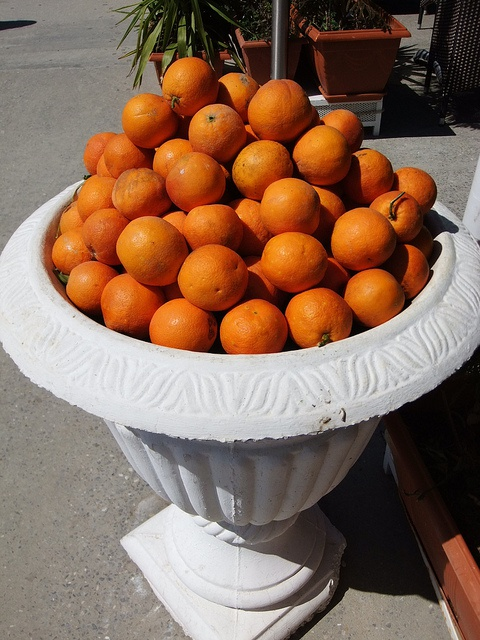Describe the objects in this image and their specific colors. I can see orange in gray, red, maroon, and orange tones, potted plant in gray, black, maroon, and brown tones, potted plant in gray, black, and darkgreen tones, orange in gray, red, maroon, and orange tones, and orange in gray, red, orange, maroon, and brown tones in this image. 